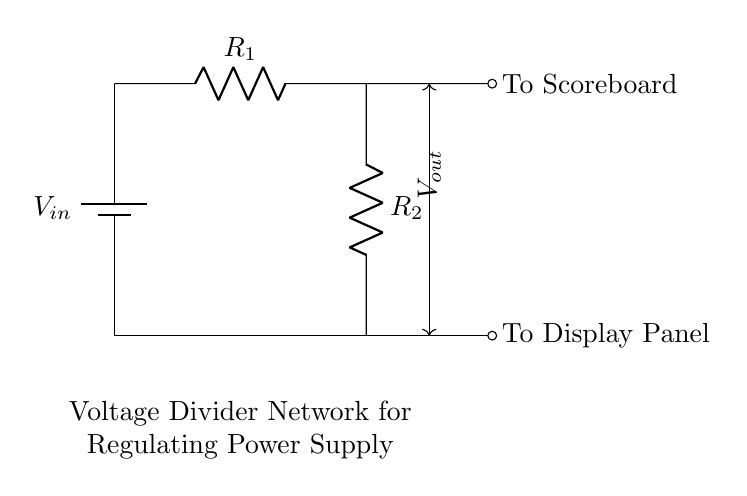What is the input voltage? The input voltage is represented by the label $V_{in}$ next to the battery symbol. This is the voltage supplied to the circuit as a power source.
Answer: $V_{in}$ What are the values of the resistors in the circuit? The resistors are denoted as $R_1$ and $R_2$. The specific values are not given in the diagram, so they are general placeholders for resistor values in a voltage divider configuration.
Answer: $R_1, R_2$ What does the output voltage signify? The output voltage $V_{out}$ is taken from the junction between the two resistors $R_1$ and $R_2$. It indicates the voltage available to the scoreboard and display panel from the divider.
Answer: $V_{out}$ How many outputs does this circuit have? The circuit has two outputs indicated; one output is directed to the scoreboard and the other to the display panel. This breakout shows the versatility of the voltage divider in powering multiple devices.
Answer: 2 How does increasing $R_2$ affect $V_{out}$? Increasing the resistance $R_2$ in a voltage divider causes the output voltage $V_{out}$ to increase, as the output voltage is influenced by the ratio of $R_2$ to the total resistance $(R_1 + R_2)$. More resistance in $R_2$ means higher voltage drop across it.
Answer: Increases $V_{out}$ What is the purpose of this voltage divider network? The purpose of the voltage divider network is to regulate the power supply to the scoreboard and display panel, ensuring that they receive an appropriate voltage level without exceeding their rated specifications.
Answer: Regulates power supply What happens if $R_1$ is much larger than $R_2$? If $R_1$ is much larger than $R_2$, the output voltage $V_{out}$ will be significantly lower due to the voltage division principle. Most of the input voltage will drop across $R_1$, resulting in insufficient voltage for the connected devices.
Answer: Lower $V_{out}$ 